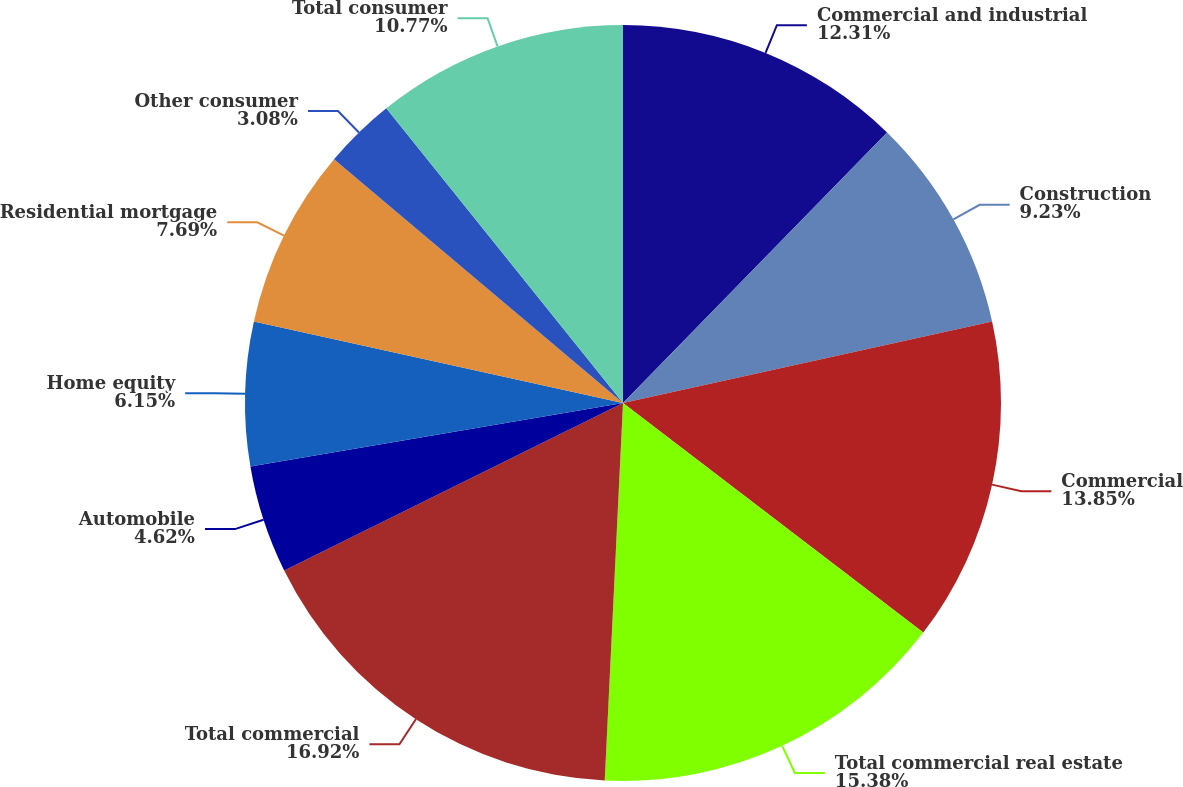<chart> <loc_0><loc_0><loc_500><loc_500><pie_chart><fcel>Commercial and industrial<fcel>Construction<fcel>Commercial<fcel>Total commercial real estate<fcel>Total commercial<fcel>Automobile<fcel>Home equity<fcel>Residential mortgage<fcel>Other consumer<fcel>Total consumer<nl><fcel>12.31%<fcel>9.23%<fcel>13.85%<fcel>15.38%<fcel>16.92%<fcel>4.62%<fcel>6.15%<fcel>7.69%<fcel>3.08%<fcel>10.77%<nl></chart> 